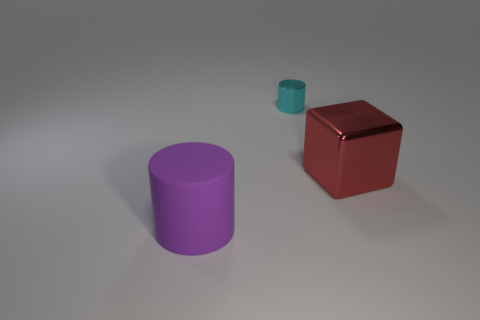Is there anything else that has the same material as the big purple cylinder?
Offer a terse response. No. There is a cyan shiny cylinder; are there any large purple rubber cylinders on the left side of it?
Offer a very short reply. Yes. Is the number of large green balls greater than the number of tiny objects?
Make the answer very short. No. There is a cylinder that is behind the big thing to the right of the cylinder that is behind the red metal cube; what is its color?
Ensure brevity in your answer.  Cyan. The small cylinder that is the same material as the red cube is what color?
Your response must be concise. Cyan. Is there anything else that has the same size as the cyan metal object?
Offer a very short reply. No. What number of things are cylinders that are in front of the shiny cube or objects behind the large purple matte object?
Your answer should be very brief. 3. Is the size of the thing that is in front of the large red metal block the same as the shiny thing in front of the shiny cylinder?
Ensure brevity in your answer.  Yes. There is a tiny thing that is the same shape as the large purple rubber thing; what is its color?
Offer a terse response. Cyan. Is there anything else that is the same shape as the large red thing?
Offer a terse response. No. 